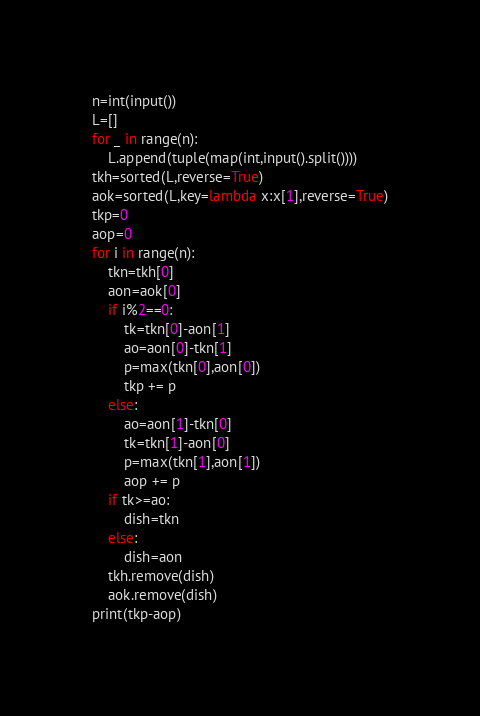<code> <loc_0><loc_0><loc_500><loc_500><_Python_>n=int(input())
L=[]
for _ in range(n):
    L.append(tuple(map(int,input().split())))
tkh=sorted(L,reverse=True)
aok=sorted(L,key=lambda x:x[1],reverse=True)
tkp=0
aop=0
for i in range(n):
    tkn=tkh[0]
    aon=aok[0]
    if i%2==0:
        tk=tkn[0]-aon[1]
        ao=aon[0]-tkn[1]
        p=max(tkn[0],aon[0])
        tkp += p
    else:
        ao=aon[1]-tkn[0]
        tk=tkn[1]-aon[0]
        p=max(tkn[1],aon[1])
        aop += p
    if tk>=ao:
        dish=tkn
    else:
        dish=aon
    tkh.remove(dish)
    aok.remove(dish)
print(tkp-aop)</code> 